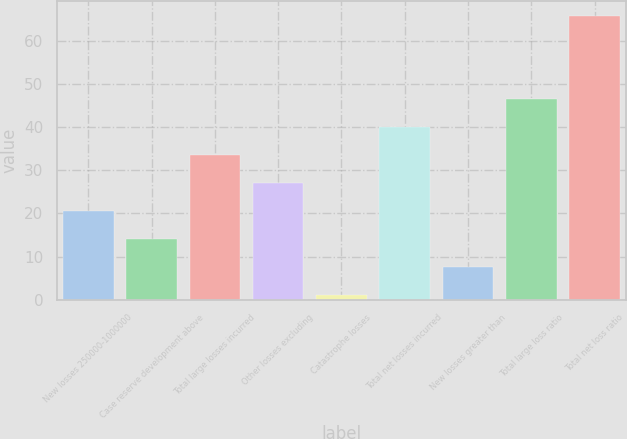Convert chart to OTSL. <chart><loc_0><loc_0><loc_500><loc_500><bar_chart><fcel>New losses 250000-1000000<fcel>Case reserve development above<fcel>Total large losses incurred<fcel>Other losses excluding<fcel>Catastrophe losses<fcel>Total net losses incurred<fcel>New losses greater than<fcel>Total large loss ratio<fcel>Total net loss ratio<nl><fcel>20.47<fcel>13.98<fcel>33.45<fcel>26.96<fcel>1<fcel>39.94<fcel>7.49<fcel>46.43<fcel>65.9<nl></chart> 